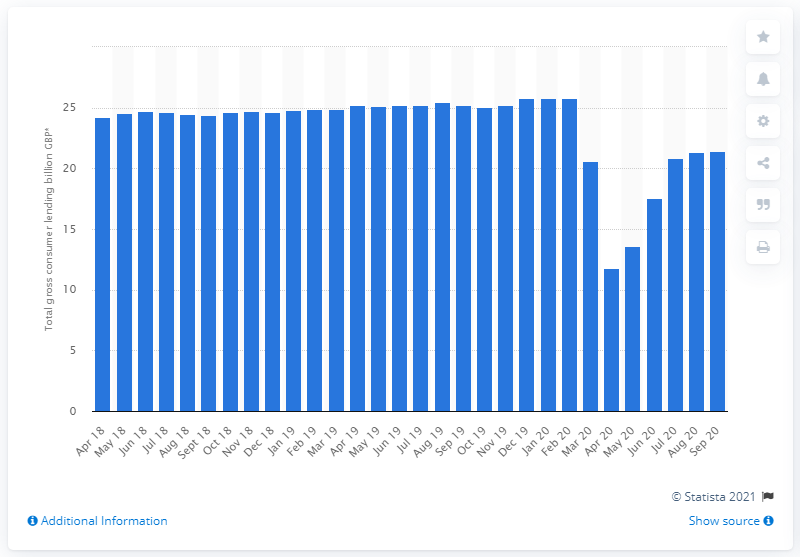Highlight a few significant elements in this photo. The total amount of consumer lending in the UK in September 2020 was 20.82. 